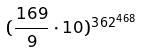Convert formula to latex. <formula><loc_0><loc_0><loc_500><loc_500>( \frac { 1 6 9 } { 9 } \cdot 1 0 ) ^ { 3 6 2 ^ { 4 6 8 } }</formula> 